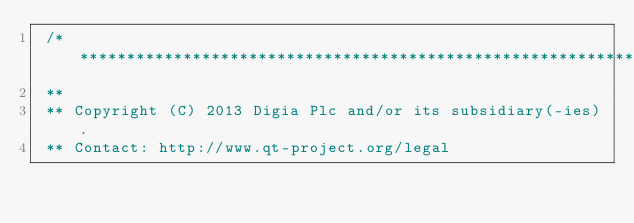Convert code to text. <code><loc_0><loc_0><loc_500><loc_500><_C_> /****************************************************************************
 **
 ** Copyright (C) 2013 Digia Plc and/or its subsidiary(-ies).
 ** Contact: http://www.qt-project.org/legal</code> 